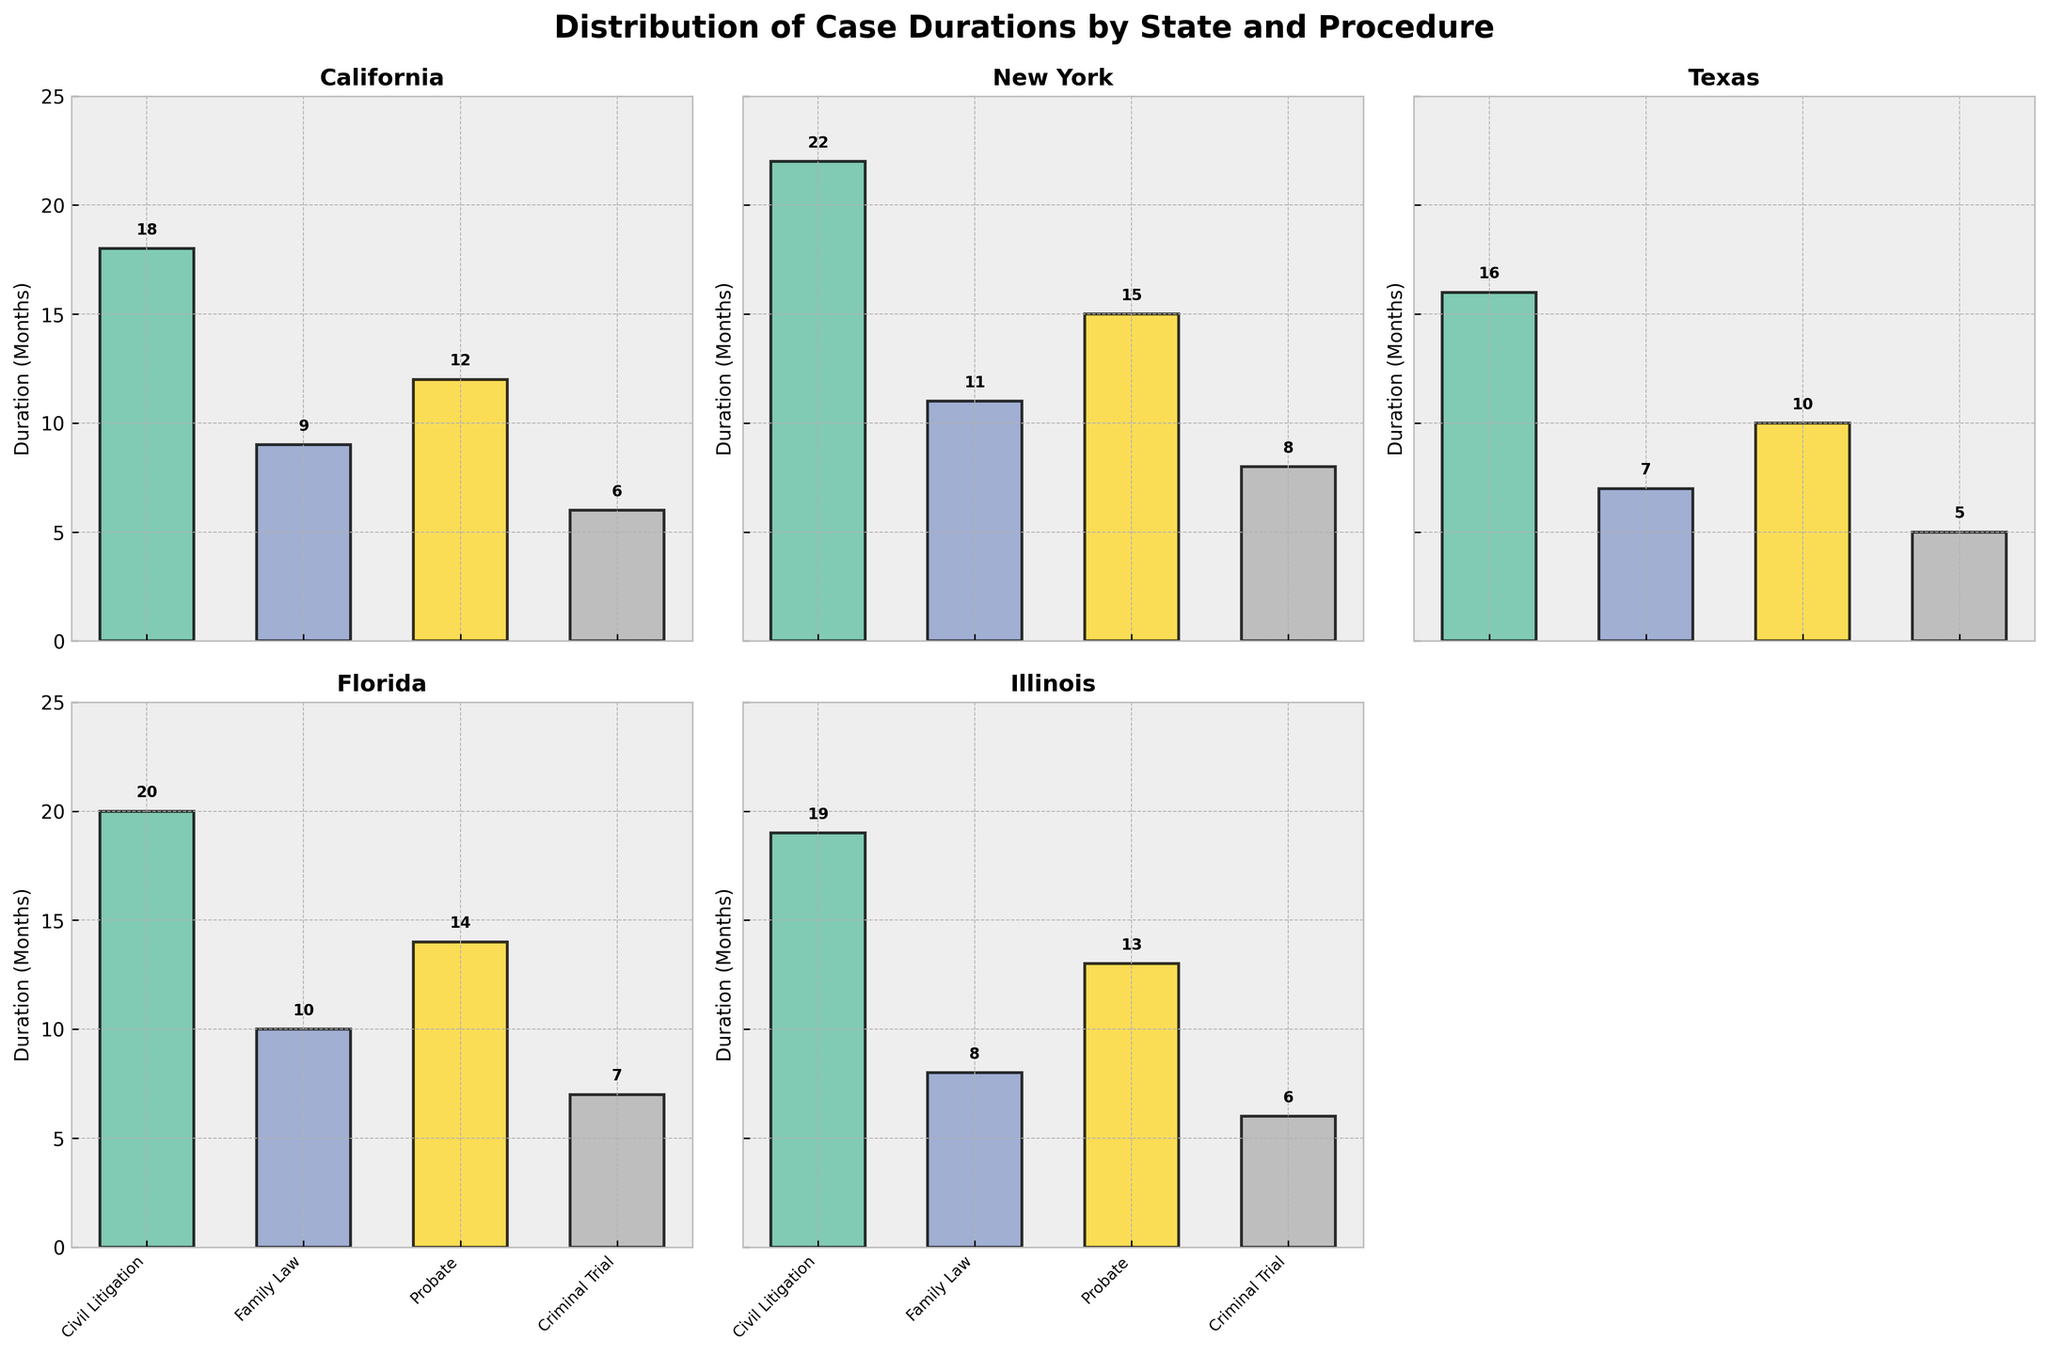What's the title of the figure? The title of the figure is located at the top of the plot in bold font.
Answer: Distribution of Case Durations by State and Procedure Which state has the longest average case duration for Civil Litigation? In the subplot for each state, the bar heights indicate the average case durations. The longest Civil Litigation duration is identified by the tallest bar in the Civil Litigation category.
Answer: New York How many subplots are there in total? The figure consists of a grid of subplots arranged in 2 rows and 3 columns. All subplots are used except one empty subplot.
Answer: 5 What's the average duration for Probate cases in Illinois? In the subplot for Illinois, find the bar labeled "Probate" and note its height.
Answer: 13 months Which legal procedure has the shortest average duration across all states? Review all subplots and identify the legal procedure with the lowest bar heights across all states.
Answer: Criminal Trial Compare the average duration of Family Law cases in California and Texas. Which state has a shorter duration? Locate the Family Law category in the subplots for California and Texas and compare the bar heights.
Answer: Texas What's the combined average duration for Criminal Trial cases in Florida and Illinois? Locate Criminal Trial bars in both Florida and Illinois subplots. Add their durations together.
Answer: 7 + 6 = 13 months Which state has the most similar average durations for Family Law and Criminal Trial procedures? Examine the heights of the Family Law and Criminal Trial bars in each state's subplot. The smallest difference between these two bars will indicate similarity.
Answer: Texas (difference is 2 months) For Civil Litigation, which state shows the largest duration difference compared to Texas? Identify the Civil Litigation bar in the Texas subplot. Then, compare it with Civil Litigation bars in all other states and find the largest discrepancy.
Answer: New York (6-month difference) 